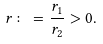<formula> <loc_0><loc_0><loc_500><loc_500>r \colon = \frac { r _ { 1 } } { r _ { 2 } } > 0 .</formula> 